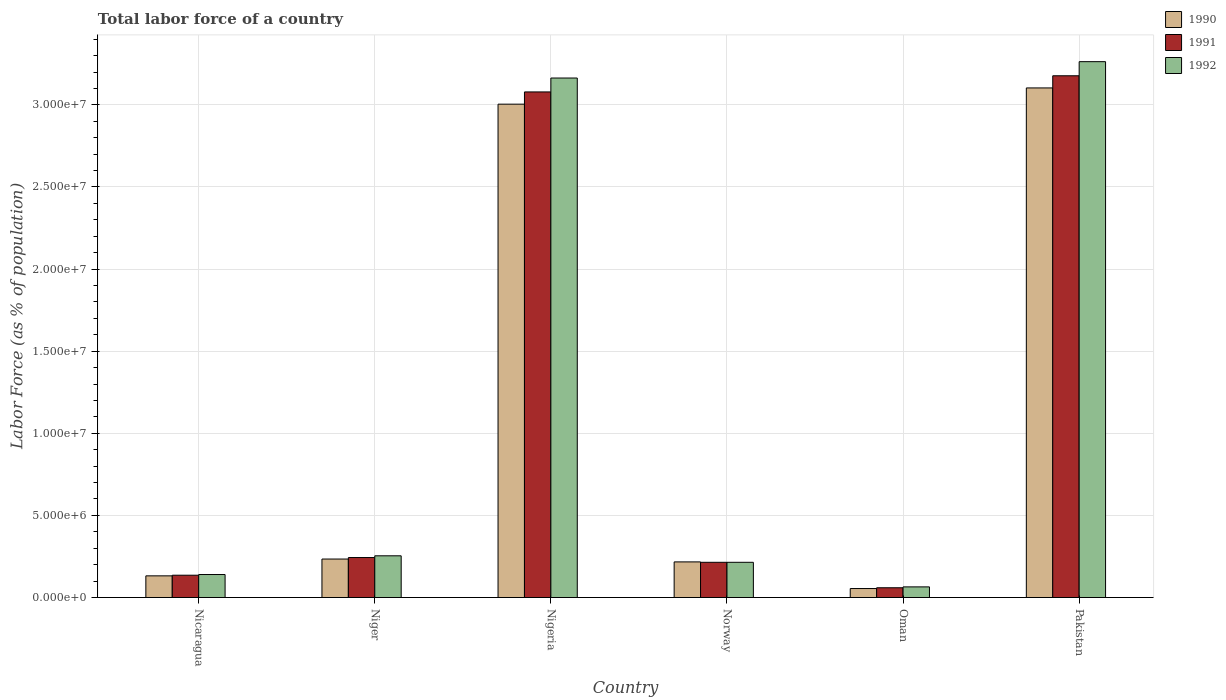How many different coloured bars are there?
Your answer should be compact. 3. How many groups of bars are there?
Ensure brevity in your answer.  6. Are the number of bars per tick equal to the number of legend labels?
Keep it short and to the point. Yes. What is the label of the 5th group of bars from the left?
Your answer should be very brief. Oman. In how many cases, is the number of bars for a given country not equal to the number of legend labels?
Offer a terse response. 0. What is the percentage of labor force in 1990 in Norway?
Your answer should be compact. 2.17e+06. Across all countries, what is the maximum percentage of labor force in 1991?
Provide a succinct answer. 3.18e+07. Across all countries, what is the minimum percentage of labor force in 1992?
Keep it short and to the point. 6.48e+05. In which country was the percentage of labor force in 1992 maximum?
Your answer should be very brief. Pakistan. In which country was the percentage of labor force in 1990 minimum?
Your response must be concise. Oman. What is the total percentage of labor force in 1990 in the graph?
Give a very brief answer. 6.75e+07. What is the difference between the percentage of labor force in 1990 in Norway and that in Pakistan?
Your answer should be very brief. -2.89e+07. What is the difference between the percentage of labor force in 1990 in Oman and the percentage of labor force in 1991 in Pakistan?
Make the answer very short. -3.12e+07. What is the average percentage of labor force in 1991 per country?
Offer a very short reply. 1.15e+07. What is the difference between the percentage of labor force of/in 1991 and percentage of labor force of/in 1992 in Oman?
Offer a very short reply. -5.39e+04. What is the ratio of the percentage of labor force in 1990 in Norway to that in Pakistan?
Your answer should be very brief. 0.07. Is the percentage of labor force in 1992 in Nigeria less than that in Pakistan?
Give a very brief answer. Yes. Is the difference between the percentage of labor force in 1991 in Nicaragua and Norway greater than the difference between the percentage of labor force in 1992 in Nicaragua and Norway?
Make the answer very short. No. What is the difference between the highest and the second highest percentage of labor force in 1991?
Your answer should be very brief. 2.93e+07. What is the difference between the highest and the lowest percentage of labor force in 1992?
Offer a very short reply. 3.20e+07. What does the 2nd bar from the right in Pakistan represents?
Ensure brevity in your answer.  1991. Are all the bars in the graph horizontal?
Your answer should be compact. No. What is the difference between two consecutive major ticks on the Y-axis?
Make the answer very short. 5.00e+06. Does the graph contain grids?
Provide a short and direct response. Yes. How are the legend labels stacked?
Make the answer very short. Vertical. What is the title of the graph?
Offer a very short reply. Total labor force of a country. Does "1979" appear as one of the legend labels in the graph?
Provide a short and direct response. No. What is the label or title of the Y-axis?
Make the answer very short. Labor Force (as % of population). What is the Labor Force (as % of population) in 1990 in Nicaragua?
Make the answer very short. 1.32e+06. What is the Labor Force (as % of population) in 1991 in Nicaragua?
Offer a terse response. 1.36e+06. What is the Labor Force (as % of population) of 1992 in Nicaragua?
Provide a succinct answer. 1.40e+06. What is the Labor Force (as % of population) in 1990 in Niger?
Make the answer very short. 2.34e+06. What is the Labor Force (as % of population) of 1991 in Niger?
Your answer should be very brief. 2.44e+06. What is the Labor Force (as % of population) in 1992 in Niger?
Your response must be concise. 2.54e+06. What is the Labor Force (as % of population) in 1990 in Nigeria?
Provide a succinct answer. 3.00e+07. What is the Labor Force (as % of population) in 1991 in Nigeria?
Provide a short and direct response. 3.08e+07. What is the Labor Force (as % of population) in 1992 in Nigeria?
Provide a short and direct response. 3.16e+07. What is the Labor Force (as % of population) of 1990 in Norway?
Your answer should be very brief. 2.17e+06. What is the Labor Force (as % of population) in 1991 in Norway?
Offer a terse response. 2.14e+06. What is the Labor Force (as % of population) in 1992 in Norway?
Keep it short and to the point. 2.14e+06. What is the Labor Force (as % of population) of 1990 in Oman?
Provide a short and direct response. 5.48e+05. What is the Labor Force (as % of population) of 1991 in Oman?
Your answer should be compact. 5.94e+05. What is the Labor Force (as % of population) of 1992 in Oman?
Your answer should be very brief. 6.48e+05. What is the Labor Force (as % of population) of 1990 in Pakistan?
Your response must be concise. 3.10e+07. What is the Labor Force (as % of population) of 1991 in Pakistan?
Give a very brief answer. 3.18e+07. What is the Labor Force (as % of population) of 1992 in Pakistan?
Ensure brevity in your answer.  3.26e+07. Across all countries, what is the maximum Labor Force (as % of population) of 1990?
Offer a terse response. 3.10e+07. Across all countries, what is the maximum Labor Force (as % of population) in 1991?
Provide a succinct answer. 3.18e+07. Across all countries, what is the maximum Labor Force (as % of population) in 1992?
Ensure brevity in your answer.  3.26e+07. Across all countries, what is the minimum Labor Force (as % of population) of 1990?
Give a very brief answer. 5.48e+05. Across all countries, what is the minimum Labor Force (as % of population) in 1991?
Your response must be concise. 5.94e+05. Across all countries, what is the minimum Labor Force (as % of population) of 1992?
Provide a short and direct response. 6.48e+05. What is the total Labor Force (as % of population) in 1990 in the graph?
Make the answer very short. 6.75e+07. What is the total Labor Force (as % of population) of 1991 in the graph?
Give a very brief answer. 6.91e+07. What is the total Labor Force (as % of population) of 1992 in the graph?
Your answer should be compact. 7.10e+07. What is the difference between the Labor Force (as % of population) of 1990 in Nicaragua and that in Niger?
Your answer should be very brief. -1.02e+06. What is the difference between the Labor Force (as % of population) in 1991 in Nicaragua and that in Niger?
Provide a succinct answer. -1.08e+06. What is the difference between the Labor Force (as % of population) of 1992 in Nicaragua and that in Niger?
Make the answer very short. -1.14e+06. What is the difference between the Labor Force (as % of population) of 1990 in Nicaragua and that in Nigeria?
Provide a succinct answer. -2.87e+07. What is the difference between the Labor Force (as % of population) in 1991 in Nicaragua and that in Nigeria?
Give a very brief answer. -2.94e+07. What is the difference between the Labor Force (as % of population) in 1992 in Nicaragua and that in Nigeria?
Your answer should be compact. -3.02e+07. What is the difference between the Labor Force (as % of population) in 1990 in Nicaragua and that in Norway?
Your answer should be very brief. -8.49e+05. What is the difference between the Labor Force (as % of population) of 1991 in Nicaragua and that in Norway?
Offer a very short reply. -7.86e+05. What is the difference between the Labor Force (as % of population) of 1992 in Nicaragua and that in Norway?
Offer a very short reply. -7.44e+05. What is the difference between the Labor Force (as % of population) of 1990 in Nicaragua and that in Oman?
Your response must be concise. 7.72e+05. What is the difference between the Labor Force (as % of population) of 1991 in Nicaragua and that in Oman?
Offer a very short reply. 7.64e+05. What is the difference between the Labor Force (as % of population) in 1992 in Nicaragua and that in Oman?
Your response must be concise. 7.52e+05. What is the difference between the Labor Force (as % of population) in 1990 in Nicaragua and that in Pakistan?
Your answer should be very brief. -2.97e+07. What is the difference between the Labor Force (as % of population) in 1991 in Nicaragua and that in Pakistan?
Give a very brief answer. -3.04e+07. What is the difference between the Labor Force (as % of population) in 1992 in Nicaragua and that in Pakistan?
Your answer should be very brief. -3.12e+07. What is the difference between the Labor Force (as % of population) of 1990 in Niger and that in Nigeria?
Your response must be concise. -2.77e+07. What is the difference between the Labor Force (as % of population) of 1991 in Niger and that in Nigeria?
Offer a terse response. -2.84e+07. What is the difference between the Labor Force (as % of population) in 1992 in Niger and that in Nigeria?
Offer a very short reply. -2.91e+07. What is the difference between the Labor Force (as % of population) of 1990 in Niger and that in Norway?
Keep it short and to the point. 1.74e+05. What is the difference between the Labor Force (as % of population) in 1991 in Niger and that in Norway?
Make the answer very short. 2.91e+05. What is the difference between the Labor Force (as % of population) in 1992 in Niger and that in Norway?
Your answer should be compact. 3.96e+05. What is the difference between the Labor Force (as % of population) in 1990 in Niger and that in Oman?
Keep it short and to the point. 1.80e+06. What is the difference between the Labor Force (as % of population) of 1991 in Niger and that in Oman?
Provide a succinct answer. 1.84e+06. What is the difference between the Labor Force (as % of population) of 1992 in Niger and that in Oman?
Ensure brevity in your answer.  1.89e+06. What is the difference between the Labor Force (as % of population) of 1990 in Niger and that in Pakistan?
Keep it short and to the point. -2.87e+07. What is the difference between the Labor Force (as % of population) of 1991 in Niger and that in Pakistan?
Make the answer very short. -2.93e+07. What is the difference between the Labor Force (as % of population) of 1992 in Niger and that in Pakistan?
Provide a succinct answer. -3.01e+07. What is the difference between the Labor Force (as % of population) in 1990 in Nigeria and that in Norway?
Keep it short and to the point. 2.79e+07. What is the difference between the Labor Force (as % of population) in 1991 in Nigeria and that in Norway?
Offer a very short reply. 2.86e+07. What is the difference between the Labor Force (as % of population) in 1992 in Nigeria and that in Norway?
Provide a succinct answer. 2.95e+07. What is the difference between the Labor Force (as % of population) of 1990 in Nigeria and that in Oman?
Give a very brief answer. 2.95e+07. What is the difference between the Labor Force (as % of population) of 1991 in Nigeria and that in Oman?
Your answer should be very brief. 3.02e+07. What is the difference between the Labor Force (as % of population) in 1992 in Nigeria and that in Oman?
Give a very brief answer. 3.10e+07. What is the difference between the Labor Force (as % of population) of 1990 in Nigeria and that in Pakistan?
Your answer should be very brief. -9.88e+05. What is the difference between the Labor Force (as % of population) in 1991 in Nigeria and that in Pakistan?
Give a very brief answer. -9.84e+05. What is the difference between the Labor Force (as % of population) of 1992 in Nigeria and that in Pakistan?
Your answer should be very brief. -9.96e+05. What is the difference between the Labor Force (as % of population) in 1990 in Norway and that in Oman?
Ensure brevity in your answer.  1.62e+06. What is the difference between the Labor Force (as % of population) of 1991 in Norway and that in Oman?
Provide a succinct answer. 1.55e+06. What is the difference between the Labor Force (as % of population) of 1992 in Norway and that in Oman?
Provide a short and direct response. 1.50e+06. What is the difference between the Labor Force (as % of population) in 1990 in Norway and that in Pakistan?
Ensure brevity in your answer.  -2.89e+07. What is the difference between the Labor Force (as % of population) in 1991 in Norway and that in Pakistan?
Offer a terse response. -2.96e+07. What is the difference between the Labor Force (as % of population) in 1992 in Norway and that in Pakistan?
Your answer should be very brief. -3.05e+07. What is the difference between the Labor Force (as % of population) in 1990 in Oman and that in Pakistan?
Make the answer very short. -3.05e+07. What is the difference between the Labor Force (as % of population) in 1991 in Oman and that in Pakistan?
Give a very brief answer. -3.12e+07. What is the difference between the Labor Force (as % of population) of 1992 in Oman and that in Pakistan?
Keep it short and to the point. -3.20e+07. What is the difference between the Labor Force (as % of population) of 1990 in Nicaragua and the Labor Force (as % of population) of 1991 in Niger?
Your answer should be very brief. -1.12e+06. What is the difference between the Labor Force (as % of population) of 1990 in Nicaragua and the Labor Force (as % of population) of 1992 in Niger?
Ensure brevity in your answer.  -1.22e+06. What is the difference between the Labor Force (as % of population) of 1991 in Nicaragua and the Labor Force (as % of population) of 1992 in Niger?
Give a very brief answer. -1.18e+06. What is the difference between the Labor Force (as % of population) in 1990 in Nicaragua and the Labor Force (as % of population) in 1991 in Nigeria?
Your response must be concise. -2.95e+07. What is the difference between the Labor Force (as % of population) in 1990 in Nicaragua and the Labor Force (as % of population) in 1992 in Nigeria?
Offer a terse response. -3.03e+07. What is the difference between the Labor Force (as % of population) in 1991 in Nicaragua and the Labor Force (as % of population) in 1992 in Nigeria?
Offer a very short reply. -3.03e+07. What is the difference between the Labor Force (as % of population) in 1990 in Nicaragua and the Labor Force (as % of population) in 1991 in Norway?
Your response must be concise. -8.25e+05. What is the difference between the Labor Force (as % of population) in 1990 in Nicaragua and the Labor Force (as % of population) in 1992 in Norway?
Offer a terse response. -8.25e+05. What is the difference between the Labor Force (as % of population) in 1991 in Nicaragua and the Labor Force (as % of population) in 1992 in Norway?
Keep it short and to the point. -7.86e+05. What is the difference between the Labor Force (as % of population) of 1990 in Nicaragua and the Labor Force (as % of population) of 1991 in Oman?
Keep it short and to the point. 7.26e+05. What is the difference between the Labor Force (as % of population) of 1990 in Nicaragua and the Labor Force (as % of population) of 1992 in Oman?
Give a very brief answer. 6.72e+05. What is the difference between the Labor Force (as % of population) of 1991 in Nicaragua and the Labor Force (as % of population) of 1992 in Oman?
Provide a short and direct response. 7.10e+05. What is the difference between the Labor Force (as % of population) of 1990 in Nicaragua and the Labor Force (as % of population) of 1991 in Pakistan?
Offer a very short reply. -3.05e+07. What is the difference between the Labor Force (as % of population) in 1990 in Nicaragua and the Labor Force (as % of population) in 1992 in Pakistan?
Your answer should be compact. -3.13e+07. What is the difference between the Labor Force (as % of population) of 1991 in Nicaragua and the Labor Force (as % of population) of 1992 in Pakistan?
Provide a short and direct response. -3.13e+07. What is the difference between the Labor Force (as % of population) of 1990 in Niger and the Labor Force (as % of population) of 1991 in Nigeria?
Your response must be concise. -2.84e+07. What is the difference between the Labor Force (as % of population) of 1990 in Niger and the Labor Force (as % of population) of 1992 in Nigeria?
Provide a short and direct response. -2.93e+07. What is the difference between the Labor Force (as % of population) in 1991 in Niger and the Labor Force (as % of population) in 1992 in Nigeria?
Your answer should be compact. -2.92e+07. What is the difference between the Labor Force (as % of population) of 1990 in Niger and the Labor Force (as % of population) of 1991 in Norway?
Provide a short and direct response. 1.99e+05. What is the difference between the Labor Force (as % of population) of 1990 in Niger and the Labor Force (as % of population) of 1992 in Norway?
Your answer should be compact. 1.99e+05. What is the difference between the Labor Force (as % of population) of 1991 in Niger and the Labor Force (as % of population) of 1992 in Norway?
Offer a very short reply. 2.91e+05. What is the difference between the Labor Force (as % of population) in 1990 in Niger and the Labor Force (as % of population) in 1991 in Oman?
Offer a terse response. 1.75e+06. What is the difference between the Labor Force (as % of population) of 1990 in Niger and the Labor Force (as % of population) of 1992 in Oman?
Provide a short and direct response. 1.69e+06. What is the difference between the Labor Force (as % of population) in 1991 in Niger and the Labor Force (as % of population) in 1992 in Oman?
Give a very brief answer. 1.79e+06. What is the difference between the Labor Force (as % of population) in 1990 in Niger and the Labor Force (as % of population) in 1991 in Pakistan?
Offer a very short reply. -2.94e+07. What is the difference between the Labor Force (as % of population) in 1990 in Niger and the Labor Force (as % of population) in 1992 in Pakistan?
Your response must be concise. -3.03e+07. What is the difference between the Labor Force (as % of population) of 1991 in Niger and the Labor Force (as % of population) of 1992 in Pakistan?
Your answer should be compact. -3.02e+07. What is the difference between the Labor Force (as % of population) of 1990 in Nigeria and the Labor Force (as % of population) of 1991 in Norway?
Provide a succinct answer. 2.79e+07. What is the difference between the Labor Force (as % of population) of 1990 in Nigeria and the Labor Force (as % of population) of 1992 in Norway?
Your answer should be very brief. 2.79e+07. What is the difference between the Labor Force (as % of population) in 1991 in Nigeria and the Labor Force (as % of population) in 1992 in Norway?
Provide a succinct answer. 2.86e+07. What is the difference between the Labor Force (as % of population) in 1990 in Nigeria and the Labor Force (as % of population) in 1991 in Oman?
Your answer should be compact. 2.94e+07. What is the difference between the Labor Force (as % of population) in 1990 in Nigeria and the Labor Force (as % of population) in 1992 in Oman?
Make the answer very short. 2.94e+07. What is the difference between the Labor Force (as % of population) in 1991 in Nigeria and the Labor Force (as % of population) in 1992 in Oman?
Your answer should be very brief. 3.01e+07. What is the difference between the Labor Force (as % of population) in 1990 in Nigeria and the Labor Force (as % of population) in 1991 in Pakistan?
Your response must be concise. -1.73e+06. What is the difference between the Labor Force (as % of population) of 1990 in Nigeria and the Labor Force (as % of population) of 1992 in Pakistan?
Offer a terse response. -2.59e+06. What is the difference between the Labor Force (as % of population) of 1991 in Nigeria and the Labor Force (as % of population) of 1992 in Pakistan?
Give a very brief answer. -1.84e+06. What is the difference between the Labor Force (as % of population) in 1990 in Norway and the Labor Force (as % of population) in 1991 in Oman?
Your response must be concise. 1.57e+06. What is the difference between the Labor Force (as % of population) of 1990 in Norway and the Labor Force (as % of population) of 1992 in Oman?
Offer a very short reply. 1.52e+06. What is the difference between the Labor Force (as % of population) in 1991 in Norway and the Labor Force (as % of population) in 1992 in Oman?
Keep it short and to the point. 1.50e+06. What is the difference between the Labor Force (as % of population) of 1990 in Norway and the Labor Force (as % of population) of 1991 in Pakistan?
Your answer should be very brief. -2.96e+07. What is the difference between the Labor Force (as % of population) of 1990 in Norway and the Labor Force (as % of population) of 1992 in Pakistan?
Offer a very short reply. -3.05e+07. What is the difference between the Labor Force (as % of population) in 1991 in Norway and the Labor Force (as % of population) in 1992 in Pakistan?
Your response must be concise. -3.05e+07. What is the difference between the Labor Force (as % of population) in 1990 in Oman and the Labor Force (as % of population) in 1991 in Pakistan?
Your answer should be compact. -3.12e+07. What is the difference between the Labor Force (as % of population) in 1990 in Oman and the Labor Force (as % of population) in 1992 in Pakistan?
Keep it short and to the point. -3.21e+07. What is the difference between the Labor Force (as % of population) of 1991 in Oman and the Labor Force (as % of population) of 1992 in Pakistan?
Make the answer very short. -3.20e+07. What is the average Labor Force (as % of population) of 1990 per country?
Your answer should be compact. 1.12e+07. What is the average Labor Force (as % of population) in 1991 per country?
Ensure brevity in your answer.  1.15e+07. What is the average Labor Force (as % of population) in 1992 per country?
Give a very brief answer. 1.18e+07. What is the difference between the Labor Force (as % of population) of 1990 and Labor Force (as % of population) of 1991 in Nicaragua?
Provide a short and direct response. -3.85e+04. What is the difference between the Labor Force (as % of population) in 1990 and Labor Force (as % of population) in 1992 in Nicaragua?
Your answer should be compact. -8.09e+04. What is the difference between the Labor Force (as % of population) in 1991 and Labor Force (as % of population) in 1992 in Nicaragua?
Your response must be concise. -4.24e+04. What is the difference between the Labor Force (as % of population) in 1990 and Labor Force (as % of population) in 1991 in Niger?
Offer a terse response. -9.19e+04. What is the difference between the Labor Force (as % of population) in 1990 and Labor Force (as % of population) in 1992 in Niger?
Offer a terse response. -1.97e+05. What is the difference between the Labor Force (as % of population) of 1991 and Labor Force (as % of population) of 1992 in Niger?
Make the answer very short. -1.05e+05. What is the difference between the Labor Force (as % of population) in 1990 and Labor Force (as % of population) in 1991 in Nigeria?
Make the answer very short. -7.44e+05. What is the difference between the Labor Force (as % of population) of 1990 and Labor Force (as % of population) of 1992 in Nigeria?
Offer a very short reply. -1.59e+06. What is the difference between the Labor Force (as % of population) in 1991 and Labor Force (as % of population) in 1992 in Nigeria?
Provide a succinct answer. -8.47e+05. What is the difference between the Labor Force (as % of population) of 1990 and Labor Force (as % of population) of 1991 in Norway?
Your response must be concise. 2.47e+04. What is the difference between the Labor Force (as % of population) of 1990 and Labor Force (as % of population) of 1992 in Norway?
Ensure brevity in your answer.  2.48e+04. What is the difference between the Labor Force (as % of population) in 1991 and Labor Force (as % of population) in 1992 in Norway?
Your answer should be very brief. 57. What is the difference between the Labor Force (as % of population) in 1990 and Labor Force (as % of population) in 1991 in Oman?
Keep it short and to the point. -4.68e+04. What is the difference between the Labor Force (as % of population) in 1990 and Labor Force (as % of population) in 1992 in Oman?
Offer a terse response. -1.01e+05. What is the difference between the Labor Force (as % of population) in 1991 and Labor Force (as % of population) in 1992 in Oman?
Provide a short and direct response. -5.39e+04. What is the difference between the Labor Force (as % of population) in 1990 and Labor Force (as % of population) in 1991 in Pakistan?
Your answer should be very brief. -7.40e+05. What is the difference between the Labor Force (as % of population) of 1990 and Labor Force (as % of population) of 1992 in Pakistan?
Provide a short and direct response. -1.60e+06. What is the difference between the Labor Force (as % of population) in 1991 and Labor Force (as % of population) in 1992 in Pakistan?
Offer a very short reply. -8.59e+05. What is the ratio of the Labor Force (as % of population) of 1990 in Nicaragua to that in Niger?
Make the answer very short. 0.56. What is the ratio of the Labor Force (as % of population) of 1991 in Nicaragua to that in Niger?
Offer a very short reply. 0.56. What is the ratio of the Labor Force (as % of population) of 1992 in Nicaragua to that in Niger?
Give a very brief answer. 0.55. What is the ratio of the Labor Force (as % of population) in 1990 in Nicaragua to that in Nigeria?
Your answer should be very brief. 0.04. What is the ratio of the Labor Force (as % of population) in 1991 in Nicaragua to that in Nigeria?
Keep it short and to the point. 0.04. What is the ratio of the Labor Force (as % of population) in 1992 in Nicaragua to that in Nigeria?
Your response must be concise. 0.04. What is the ratio of the Labor Force (as % of population) in 1990 in Nicaragua to that in Norway?
Give a very brief answer. 0.61. What is the ratio of the Labor Force (as % of population) of 1991 in Nicaragua to that in Norway?
Make the answer very short. 0.63. What is the ratio of the Labor Force (as % of population) in 1992 in Nicaragua to that in Norway?
Make the answer very short. 0.65. What is the ratio of the Labor Force (as % of population) of 1990 in Nicaragua to that in Oman?
Your response must be concise. 2.41. What is the ratio of the Labor Force (as % of population) of 1991 in Nicaragua to that in Oman?
Offer a terse response. 2.29. What is the ratio of the Labor Force (as % of population) in 1992 in Nicaragua to that in Oman?
Provide a succinct answer. 2.16. What is the ratio of the Labor Force (as % of population) of 1990 in Nicaragua to that in Pakistan?
Offer a terse response. 0.04. What is the ratio of the Labor Force (as % of population) in 1991 in Nicaragua to that in Pakistan?
Give a very brief answer. 0.04. What is the ratio of the Labor Force (as % of population) in 1992 in Nicaragua to that in Pakistan?
Your response must be concise. 0.04. What is the ratio of the Labor Force (as % of population) of 1990 in Niger to that in Nigeria?
Your answer should be compact. 0.08. What is the ratio of the Labor Force (as % of population) in 1991 in Niger to that in Nigeria?
Provide a short and direct response. 0.08. What is the ratio of the Labor Force (as % of population) in 1992 in Niger to that in Nigeria?
Ensure brevity in your answer.  0.08. What is the ratio of the Labor Force (as % of population) of 1990 in Niger to that in Norway?
Give a very brief answer. 1.08. What is the ratio of the Labor Force (as % of population) of 1991 in Niger to that in Norway?
Your answer should be compact. 1.14. What is the ratio of the Labor Force (as % of population) in 1992 in Niger to that in Norway?
Your answer should be compact. 1.18. What is the ratio of the Labor Force (as % of population) in 1990 in Niger to that in Oman?
Keep it short and to the point. 4.28. What is the ratio of the Labor Force (as % of population) in 1991 in Niger to that in Oman?
Make the answer very short. 4.1. What is the ratio of the Labor Force (as % of population) in 1992 in Niger to that in Oman?
Your answer should be very brief. 3.92. What is the ratio of the Labor Force (as % of population) of 1990 in Niger to that in Pakistan?
Offer a very short reply. 0.08. What is the ratio of the Labor Force (as % of population) in 1991 in Niger to that in Pakistan?
Offer a very short reply. 0.08. What is the ratio of the Labor Force (as % of population) of 1992 in Niger to that in Pakistan?
Offer a very short reply. 0.08. What is the ratio of the Labor Force (as % of population) in 1990 in Nigeria to that in Norway?
Ensure brevity in your answer.  13.85. What is the ratio of the Labor Force (as % of population) of 1991 in Nigeria to that in Norway?
Keep it short and to the point. 14.36. What is the ratio of the Labor Force (as % of population) in 1992 in Nigeria to that in Norway?
Provide a short and direct response. 14.75. What is the ratio of the Labor Force (as % of population) in 1990 in Nigeria to that in Oman?
Keep it short and to the point. 54.86. What is the ratio of the Labor Force (as % of population) in 1991 in Nigeria to that in Oman?
Ensure brevity in your answer.  51.79. What is the ratio of the Labor Force (as % of population) of 1992 in Nigeria to that in Oman?
Keep it short and to the point. 48.79. What is the ratio of the Labor Force (as % of population) in 1990 in Nigeria to that in Pakistan?
Ensure brevity in your answer.  0.97. What is the ratio of the Labor Force (as % of population) in 1992 in Nigeria to that in Pakistan?
Your response must be concise. 0.97. What is the ratio of the Labor Force (as % of population) in 1990 in Norway to that in Oman?
Offer a very short reply. 3.96. What is the ratio of the Labor Force (as % of population) in 1991 in Norway to that in Oman?
Make the answer very short. 3.61. What is the ratio of the Labor Force (as % of population) in 1992 in Norway to that in Oman?
Provide a short and direct response. 3.31. What is the ratio of the Labor Force (as % of population) of 1990 in Norway to that in Pakistan?
Your answer should be compact. 0.07. What is the ratio of the Labor Force (as % of population) of 1991 in Norway to that in Pakistan?
Offer a very short reply. 0.07. What is the ratio of the Labor Force (as % of population) in 1992 in Norway to that in Pakistan?
Make the answer very short. 0.07. What is the ratio of the Labor Force (as % of population) in 1990 in Oman to that in Pakistan?
Make the answer very short. 0.02. What is the ratio of the Labor Force (as % of population) of 1991 in Oman to that in Pakistan?
Your answer should be compact. 0.02. What is the ratio of the Labor Force (as % of population) in 1992 in Oman to that in Pakistan?
Your answer should be compact. 0.02. What is the difference between the highest and the second highest Labor Force (as % of population) of 1990?
Provide a short and direct response. 9.88e+05. What is the difference between the highest and the second highest Labor Force (as % of population) of 1991?
Make the answer very short. 9.84e+05. What is the difference between the highest and the second highest Labor Force (as % of population) of 1992?
Your response must be concise. 9.96e+05. What is the difference between the highest and the lowest Labor Force (as % of population) of 1990?
Your response must be concise. 3.05e+07. What is the difference between the highest and the lowest Labor Force (as % of population) in 1991?
Offer a very short reply. 3.12e+07. What is the difference between the highest and the lowest Labor Force (as % of population) in 1992?
Provide a succinct answer. 3.20e+07. 